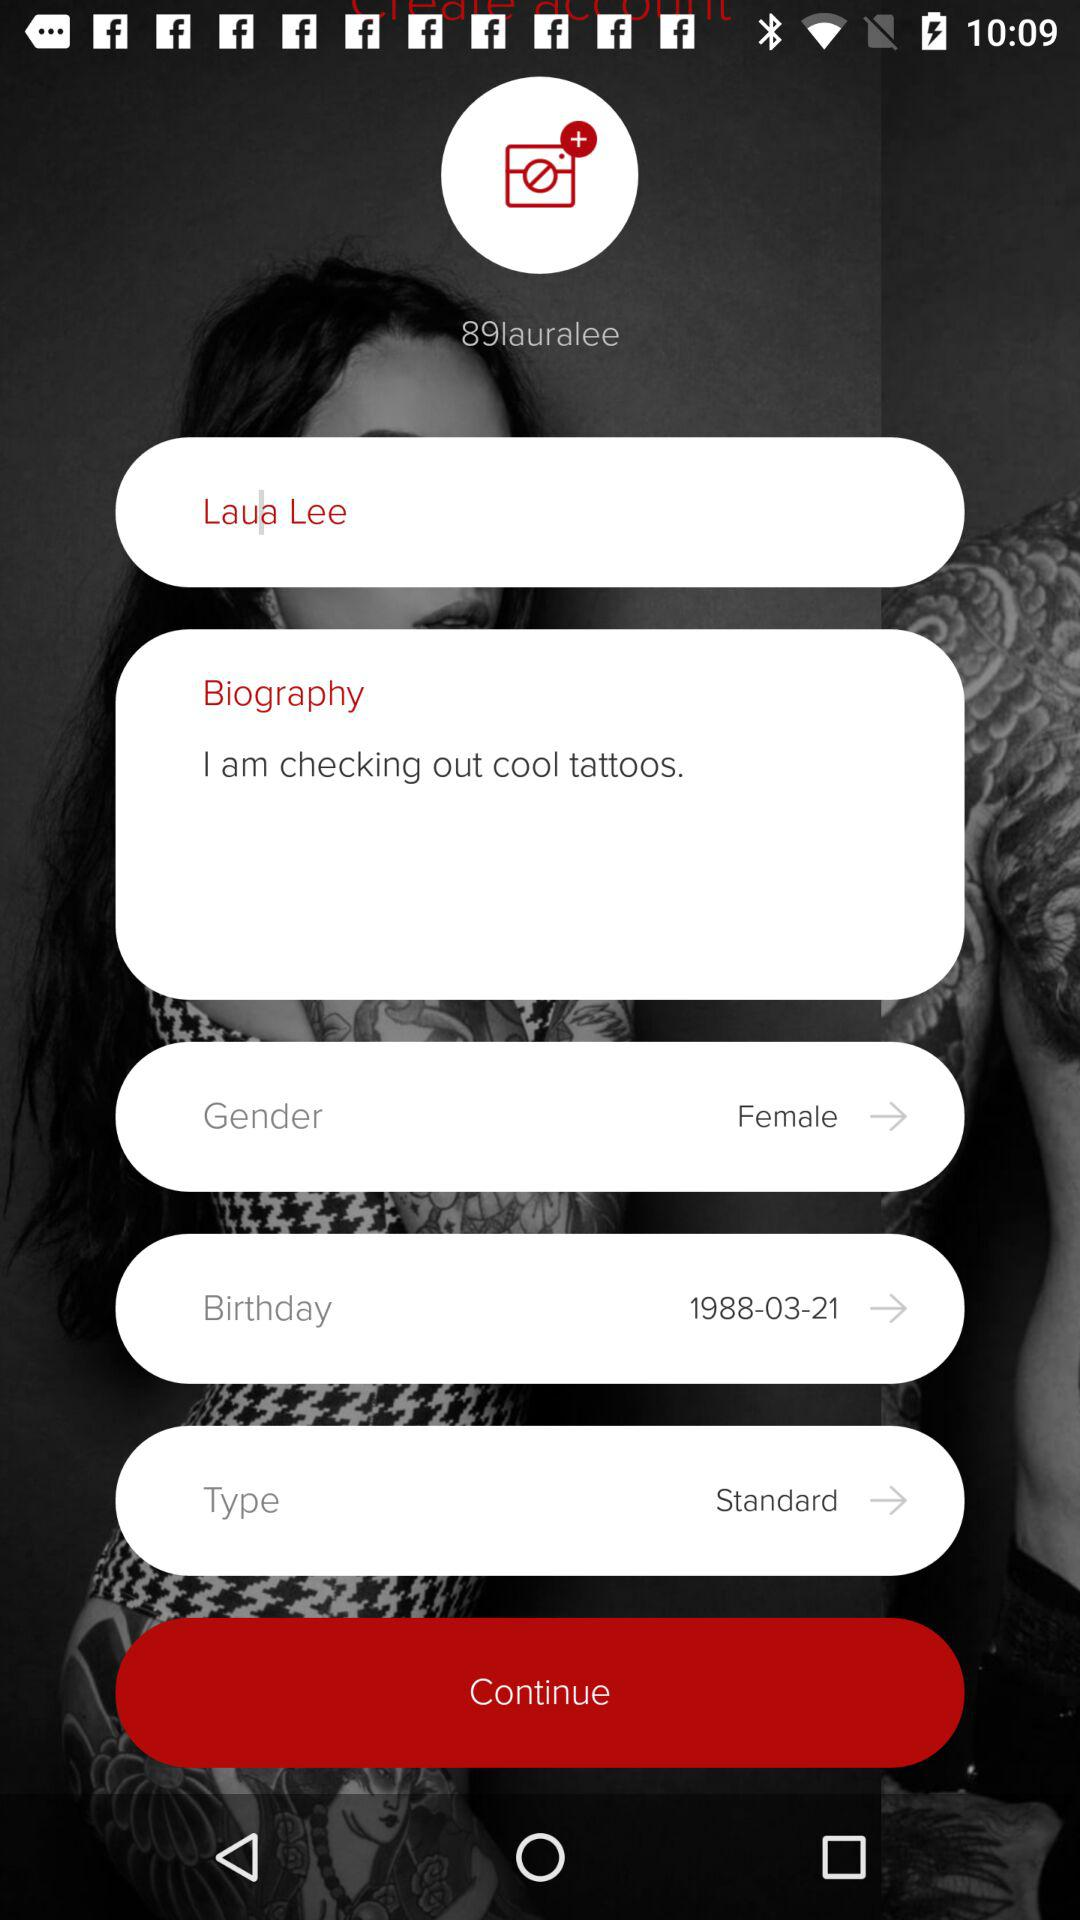What text is written in "Biography"? The text written in "Biography" is "I am checking out cool tattoos". 